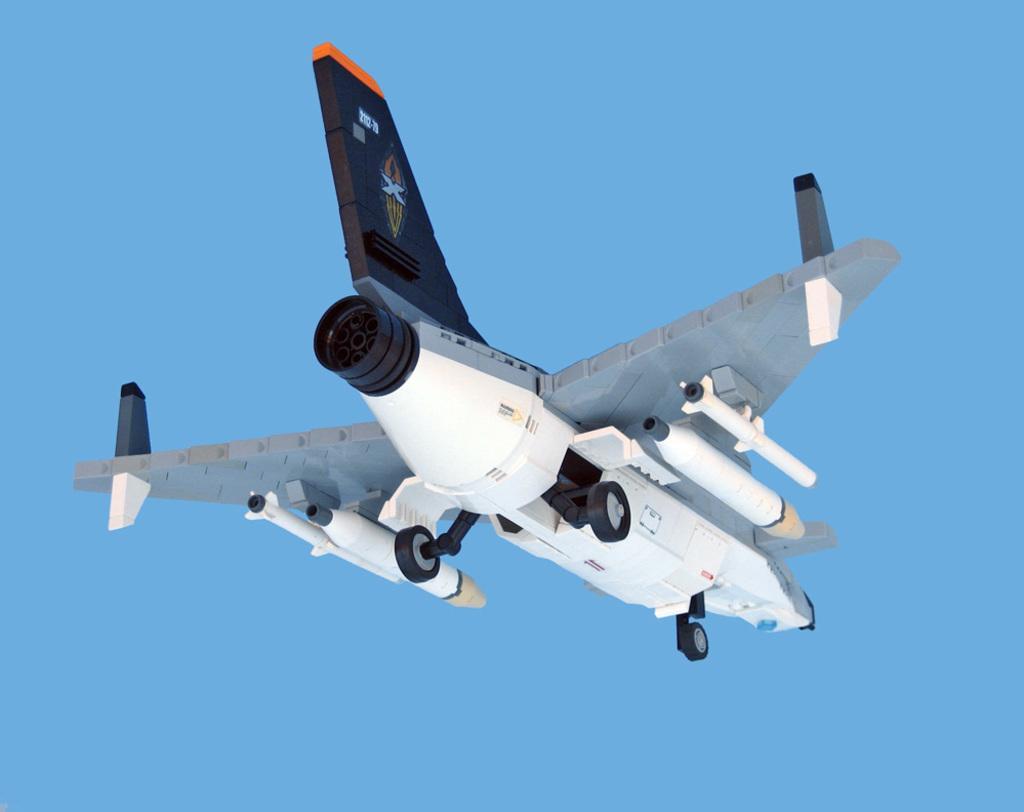Can you describe this image briefly? In this image, I can see an aircraft and a blue color background. 